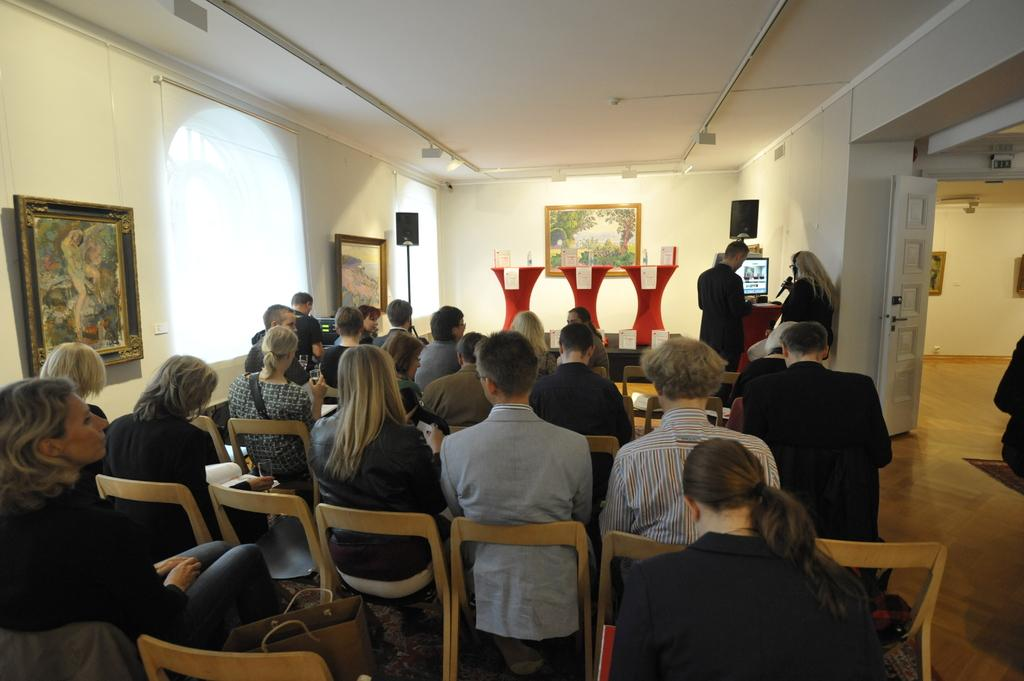What type of space is shown in the image? The image depicts a hall. What are the people in the hall doing? There are people sitting on chairs in the hall. What can be seen in front of the seated people? There are three podiums in front of the seated people. Can you see an owl perched on one of the podiums in the image? No, there is no owl present in the image. What type of form is being filled out by the people sitting in the hall? There is no form visible in the image, and the people are not shown filling out any forms. 